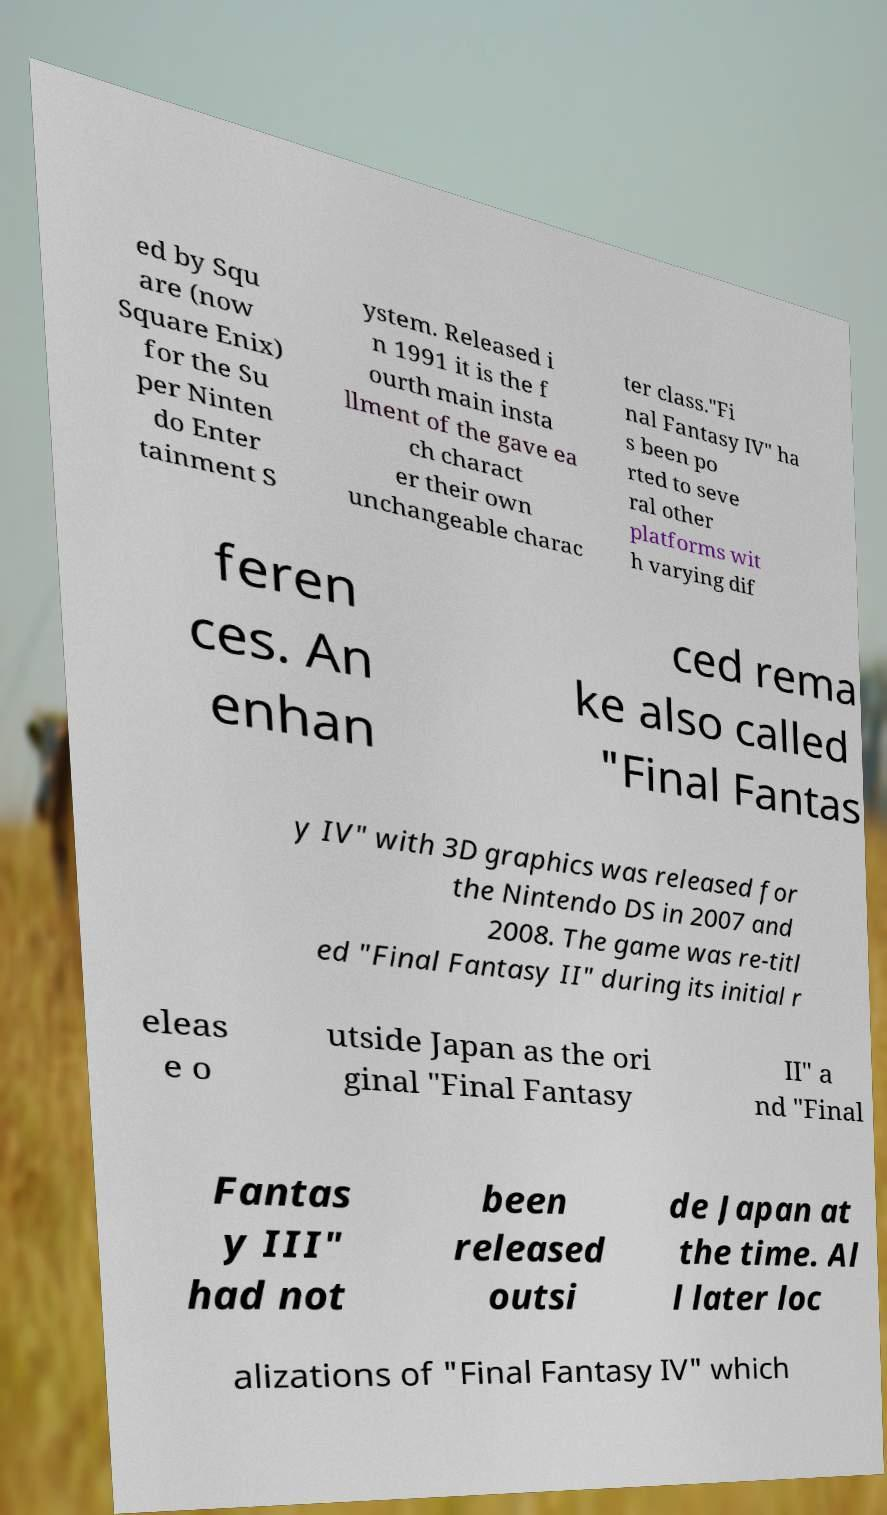I need the written content from this picture converted into text. Can you do that? ed by Squ are (now Square Enix) for the Su per Ninten do Enter tainment S ystem. Released i n 1991 it is the f ourth main insta llment of the gave ea ch charact er their own unchangeable charac ter class."Fi nal Fantasy IV" ha s been po rted to seve ral other platforms wit h varying dif feren ces. An enhan ced rema ke also called "Final Fantas y IV" with 3D graphics was released for the Nintendo DS in 2007 and 2008. The game was re-titl ed "Final Fantasy II" during its initial r eleas e o utside Japan as the ori ginal "Final Fantasy II" a nd "Final Fantas y III" had not been released outsi de Japan at the time. Al l later loc alizations of "Final Fantasy IV" which 